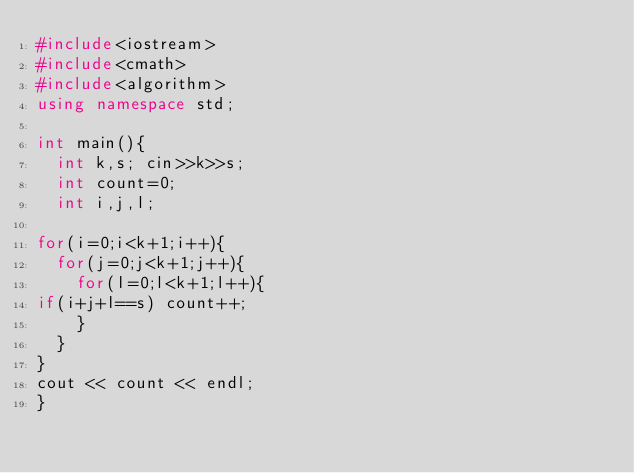<code> <loc_0><loc_0><loc_500><loc_500><_C++_>#include<iostream>
#include<cmath>
#include<algorithm>
using namespace std;

int main(){
  int k,s; cin>>k>>s;
  int count=0;
  int i,j,l;

for(i=0;i<k+1;i++){
  for(j=0;j<k+1;j++){
    for(l=0;l<k+1;l++){
if(i+j+l==s) count++;
    }
  }
}
cout << count << endl;
}
</code> 